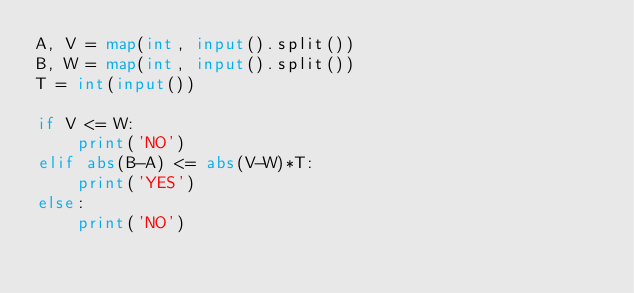Convert code to text. <code><loc_0><loc_0><loc_500><loc_500><_Python_>A, V = map(int, input().split())
B, W = map(int, input().split())
T = int(input())

if V <= W:
    print('NO')
elif abs(B-A) <= abs(V-W)*T:
    print('YES')
else:
    print('NO')
</code> 